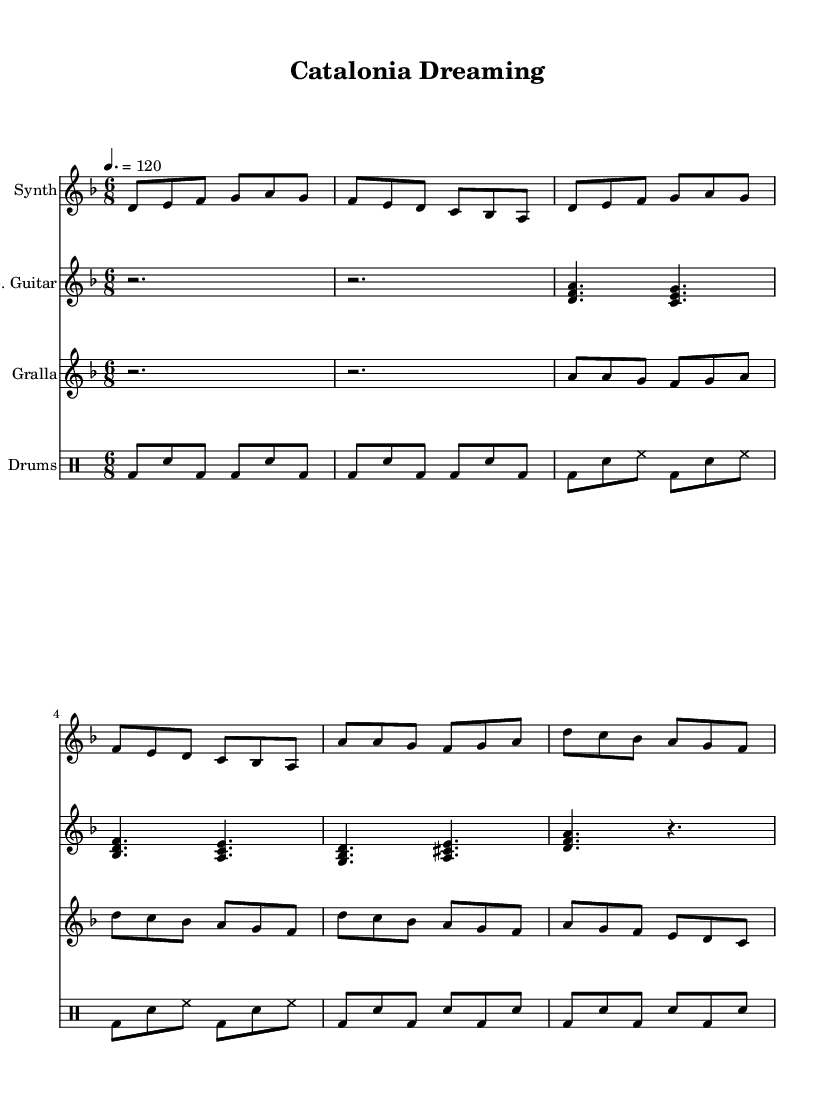What is the key signature of this music? The key signature is based on the first measure's initial note, which indicates D minor or F major. In this case, D minor has one flat (B flat).
Answer: D minor What is the time signature of this music? The time signature is indicated at the beginning of the score, showing the number of beats per measure and the note value that gets one beat. Here, it displays "6/8," meaning there are six eighth-note beats in each measure.
Answer: 6/8 What is the tempo marking for this piece? The tempo marking is stated at the beginning of the score, indicating the speed of the music. It shows "4. = 120," which refers to 120 beats per minute with a quarter note as the reference beat.
Answer: 120 How many measures are in the verse section? By analyzing the score, the verse section consists of a repeating structure that can be counted. The verse appears twice, and each instance has four measures, leading to a total of eight measures.
Answer: 8 What instruments are used in this composition? Observing the staff names, there are four instruments present: Synth, Electric Guitar, Gralla, and Drums, as indicated at the beginning of each staff.
Answer: Synth, Electric Guitar, Gralla, Drums What structural form does the music follow? The structure can be identified by the sections labeled in the sheet music. It includes an Intro, followed by a Verse section repeated, and culminating in a Chorus after the Verse, indicating a typical song structure of intro-verse-chorus.
Answer: Intro-Verse-Chorus 